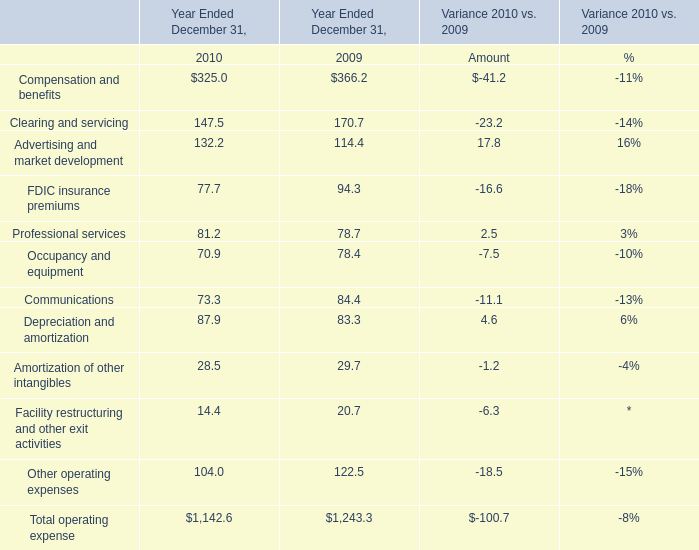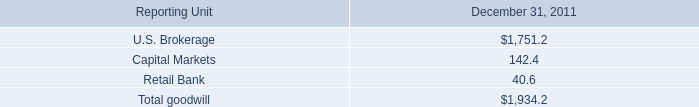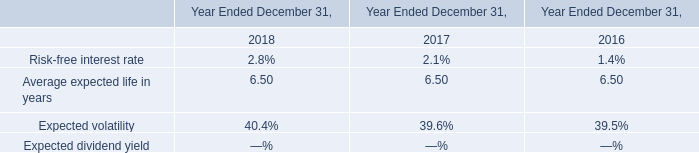In the year with largest amount of Operating revenues, what's the sum of operating expense? 
Computations: ((((((((((366.2 + 170.7) + 114.4) + 94.3) + 78.7) + 78.4) + 84.4) + 83.3) + 29.7) + 20.7) + 122.5)
Answer: 1243.3. 